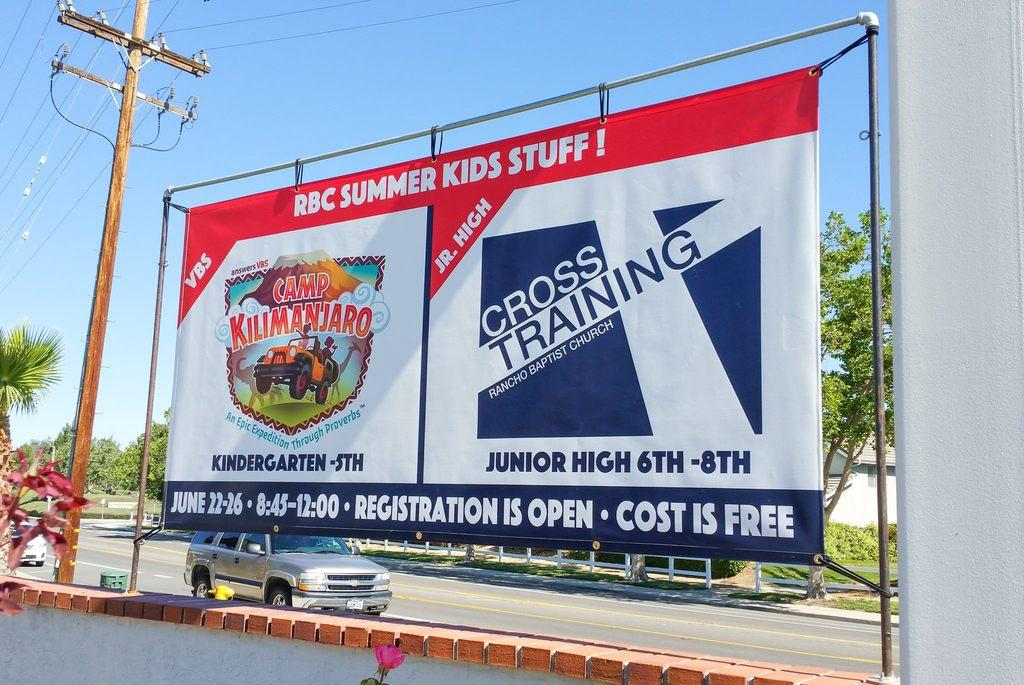<image>
Relay a brief, clear account of the picture shown. A large advertisement for Kilimanjaro and Cross training are hanging in view of the street next to it. 